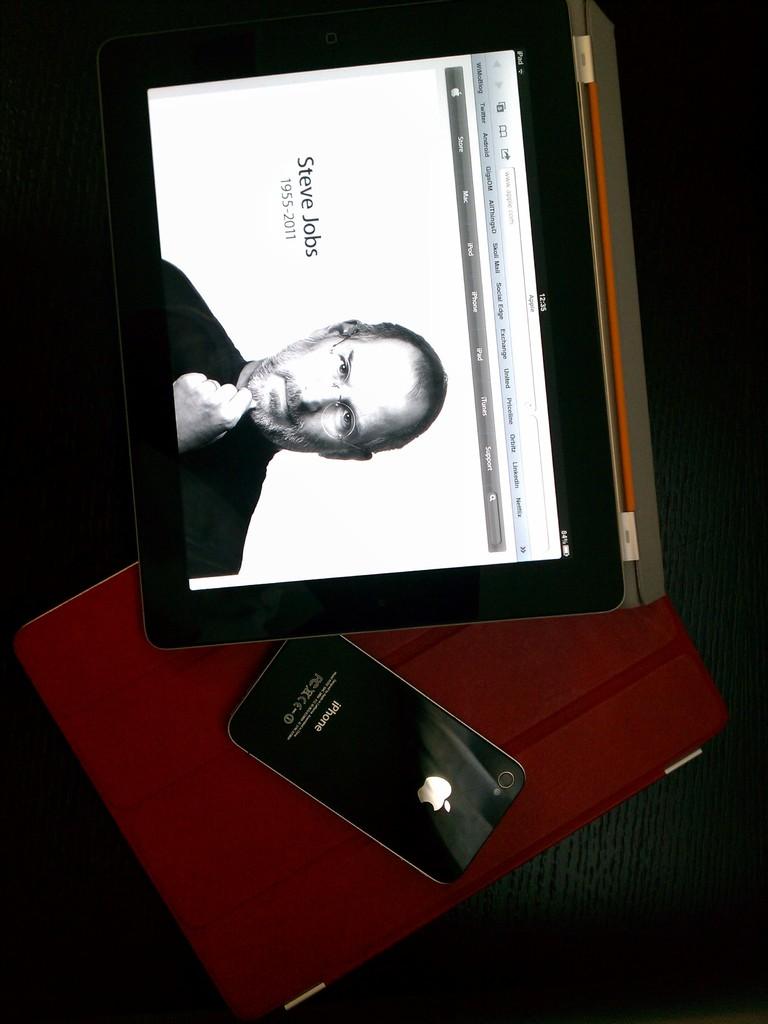What brand of tablet is this?
Provide a short and direct response. Apple. Who's the man displayed in the screen?
Provide a succinct answer. Steve jobs. 